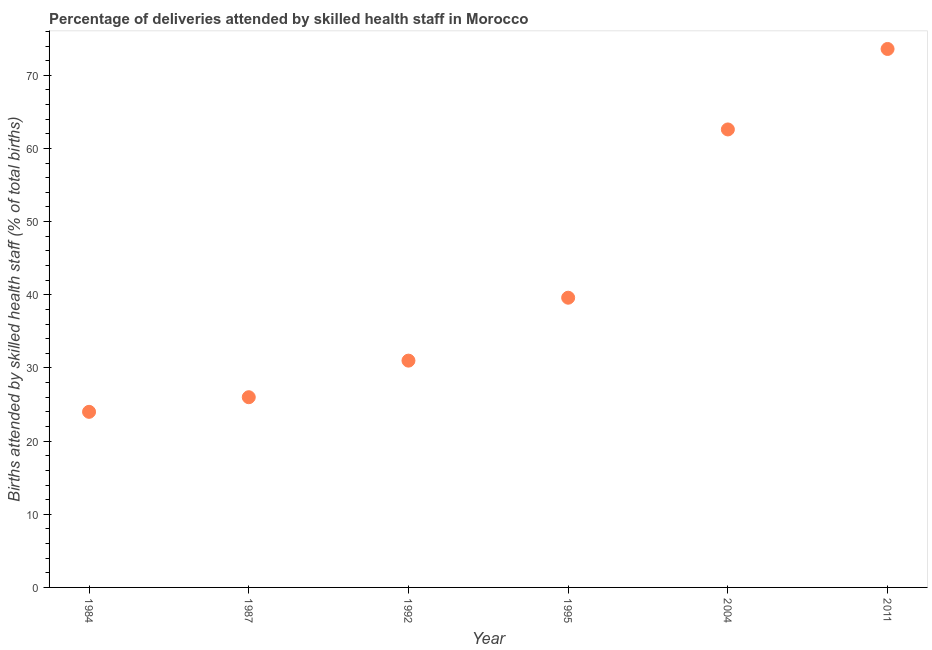Across all years, what is the maximum number of births attended by skilled health staff?
Your answer should be compact. 73.6. Across all years, what is the minimum number of births attended by skilled health staff?
Provide a short and direct response. 24. In which year was the number of births attended by skilled health staff minimum?
Your response must be concise. 1984. What is the sum of the number of births attended by skilled health staff?
Keep it short and to the point. 256.8. What is the difference between the number of births attended by skilled health staff in 1992 and 2011?
Your answer should be compact. -42.6. What is the average number of births attended by skilled health staff per year?
Make the answer very short. 42.8. What is the median number of births attended by skilled health staff?
Provide a short and direct response. 35.3. In how many years, is the number of births attended by skilled health staff greater than 44 %?
Keep it short and to the point. 2. What is the ratio of the number of births attended by skilled health staff in 1992 to that in 1995?
Offer a terse response. 0.78. Is the number of births attended by skilled health staff in 1992 less than that in 1995?
Your answer should be very brief. Yes. Is the difference between the number of births attended by skilled health staff in 1987 and 2004 greater than the difference between any two years?
Ensure brevity in your answer.  No. What is the difference between the highest and the second highest number of births attended by skilled health staff?
Ensure brevity in your answer.  11. Is the sum of the number of births attended by skilled health staff in 1984 and 1995 greater than the maximum number of births attended by skilled health staff across all years?
Provide a short and direct response. No. What is the difference between the highest and the lowest number of births attended by skilled health staff?
Your answer should be compact. 49.6. Does the number of births attended by skilled health staff monotonically increase over the years?
Offer a very short reply. Yes. How many dotlines are there?
Keep it short and to the point. 1. How many years are there in the graph?
Your answer should be very brief. 6. Does the graph contain any zero values?
Ensure brevity in your answer.  No. What is the title of the graph?
Your answer should be very brief. Percentage of deliveries attended by skilled health staff in Morocco. What is the label or title of the Y-axis?
Your answer should be compact. Births attended by skilled health staff (% of total births). What is the Births attended by skilled health staff (% of total births) in 1984?
Your response must be concise. 24. What is the Births attended by skilled health staff (% of total births) in 1987?
Provide a succinct answer. 26. What is the Births attended by skilled health staff (% of total births) in 1995?
Offer a very short reply. 39.6. What is the Births attended by skilled health staff (% of total births) in 2004?
Provide a short and direct response. 62.6. What is the Births attended by skilled health staff (% of total births) in 2011?
Your response must be concise. 73.6. What is the difference between the Births attended by skilled health staff (% of total births) in 1984 and 1987?
Give a very brief answer. -2. What is the difference between the Births attended by skilled health staff (% of total births) in 1984 and 1995?
Ensure brevity in your answer.  -15.6. What is the difference between the Births attended by skilled health staff (% of total births) in 1984 and 2004?
Provide a succinct answer. -38.6. What is the difference between the Births attended by skilled health staff (% of total births) in 1984 and 2011?
Your answer should be very brief. -49.6. What is the difference between the Births attended by skilled health staff (% of total births) in 1987 and 2004?
Offer a very short reply. -36.6. What is the difference between the Births attended by skilled health staff (% of total births) in 1987 and 2011?
Provide a succinct answer. -47.6. What is the difference between the Births attended by skilled health staff (% of total births) in 1992 and 1995?
Keep it short and to the point. -8.6. What is the difference between the Births attended by skilled health staff (% of total births) in 1992 and 2004?
Offer a terse response. -31.6. What is the difference between the Births attended by skilled health staff (% of total births) in 1992 and 2011?
Your response must be concise. -42.6. What is the difference between the Births attended by skilled health staff (% of total births) in 1995 and 2004?
Ensure brevity in your answer.  -23. What is the difference between the Births attended by skilled health staff (% of total births) in 1995 and 2011?
Your answer should be compact. -34. What is the ratio of the Births attended by skilled health staff (% of total births) in 1984 to that in 1987?
Offer a very short reply. 0.92. What is the ratio of the Births attended by skilled health staff (% of total births) in 1984 to that in 1992?
Offer a terse response. 0.77. What is the ratio of the Births attended by skilled health staff (% of total births) in 1984 to that in 1995?
Provide a short and direct response. 0.61. What is the ratio of the Births attended by skilled health staff (% of total births) in 1984 to that in 2004?
Make the answer very short. 0.38. What is the ratio of the Births attended by skilled health staff (% of total births) in 1984 to that in 2011?
Give a very brief answer. 0.33. What is the ratio of the Births attended by skilled health staff (% of total births) in 1987 to that in 1992?
Make the answer very short. 0.84. What is the ratio of the Births attended by skilled health staff (% of total births) in 1987 to that in 1995?
Ensure brevity in your answer.  0.66. What is the ratio of the Births attended by skilled health staff (% of total births) in 1987 to that in 2004?
Your answer should be very brief. 0.41. What is the ratio of the Births attended by skilled health staff (% of total births) in 1987 to that in 2011?
Offer a very short reply. 0.35. What is the ratio of the Births attended by skilled health staff (% of total births) in 1992 to that in 1995?
Provide a succinct answer. 0.78. What is the ratio of the Births attended by skilled health staff (% of total births) in 1992 to that in 2004?
Your answer should be compact. 0.49. What is the ratio of the Births attended by skilled health staff (% of total births) in 1992 to that in 2011?
Keep it short and to the point. 0.42. What is the ratio of the Births attended by skilled health staff (% of total births) in 1995 to that in 2004?
Provide a succinct answer. 0.63. What is the ratio of the Births attended by skilled health staff (% of total births) in 1995 to that in 2011?
Give a very brief answer. 0.54. What is the ratio of the Births attended by skilled health staff (% of total births) in 2004 to that in 2011?
Provide a short and direct response. 0.85. 